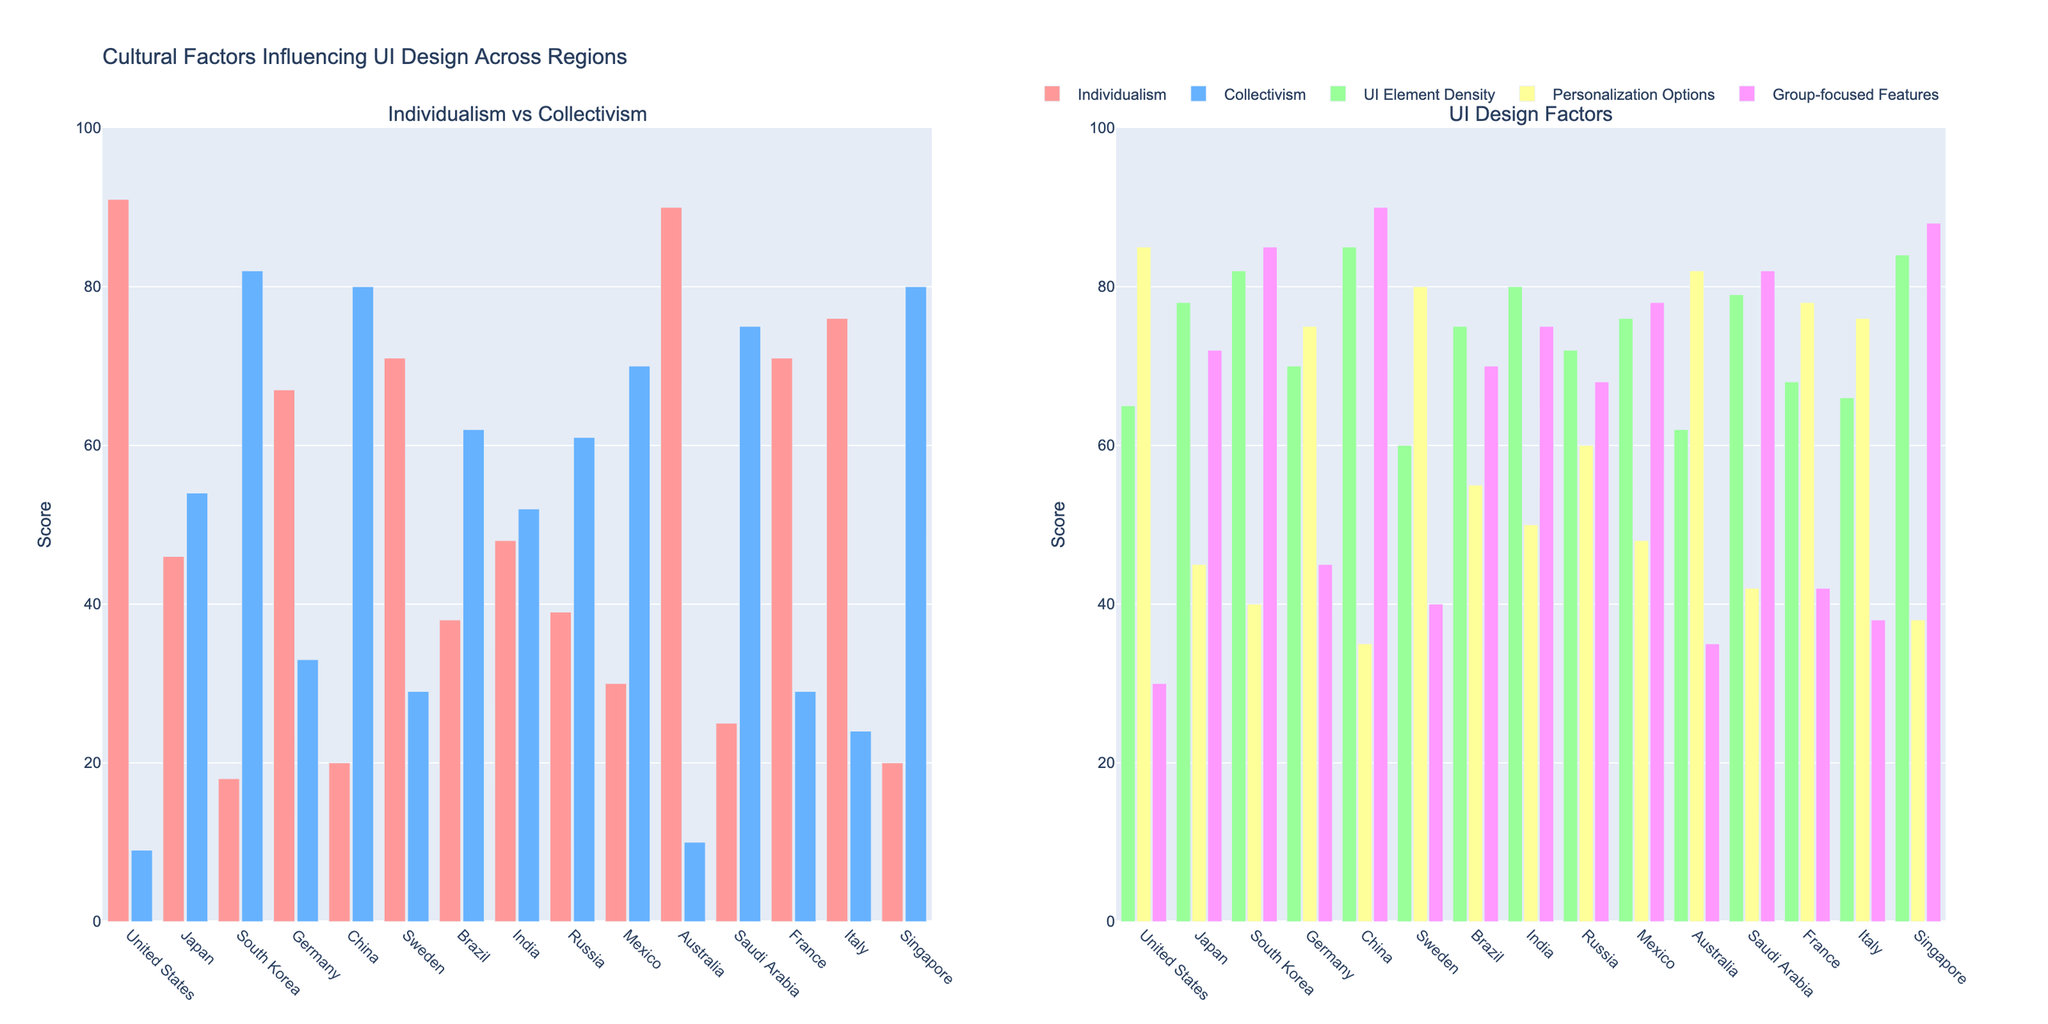What region has the highest individualism score? Look at the left subplot and identify the tallest bar in the "Individualism" category. The United States has the highest individualism score of 91.
Answer: United States Which region has a higher collectivism score, Japan or Germany? Compare the heights of the bars for "Collectivism" in Japan and Germany in the left subplot. Japan has a taller bar with a score of 54 compared to Germany's 33.
Answer: Japan Which region features the highest UI element density score? Look at the right subplot and identify the tallest bar in the "UI Element Density" category. China has the highest UI element density score of 85.
Answer: China What is the sum of personalization options for Brazil and France? Locate the bars for "Personalization Options" for Brazil and France in the right subplot. Brazil has a score of 55 and France has a score of 78. Adding them together, \(55 + 78 = 133\).
Answer: 133 Which region has the closest scores between individualism and collectivism? Examine the left subplot to find the region where the bars for "Individualism" and "Collectivism" are closest in height. Russia has individualism and collectivism scores of 39 and 61 respectively, showing a difference of 22.
Answer: Russia Which region has the most significant difference between personalization options and group-focused features? In the right subplot, calculate the difference for each region, and identify the largest one. For Australia, personalization options are 82, and group-focused features are 35, making a difference of \(82 - 35 = 47\). This difference is the largest among all regions.
Answer: Australia How does South Korea's score in group-focused features compare to that of Sweden? Compare the heights of the bars for "Group-focused Features" for South Korea and Sweden in the right subplot. South Korea has a score of 85, while Sweden has 40. South Korea's score is higher.
Answer: South Korea What is the average individualism score for the United States, Sweden, and Australia? Find the individualism scores of the United States (91), Sweden (71), and Australia (90) from the left subplot. Sum these scores: \(91 + 71 + 90 = 252\), then divide by 3 to find the average: \(252 / 3 = 84\).
Answer: 84 Which two regions have the same score in group-focused features, and what is that score? In the right subplot, visually inspect and identify that Japan and Mexico both have a group-focused features score of 78.
Answer: Japan and Mexico, 78 